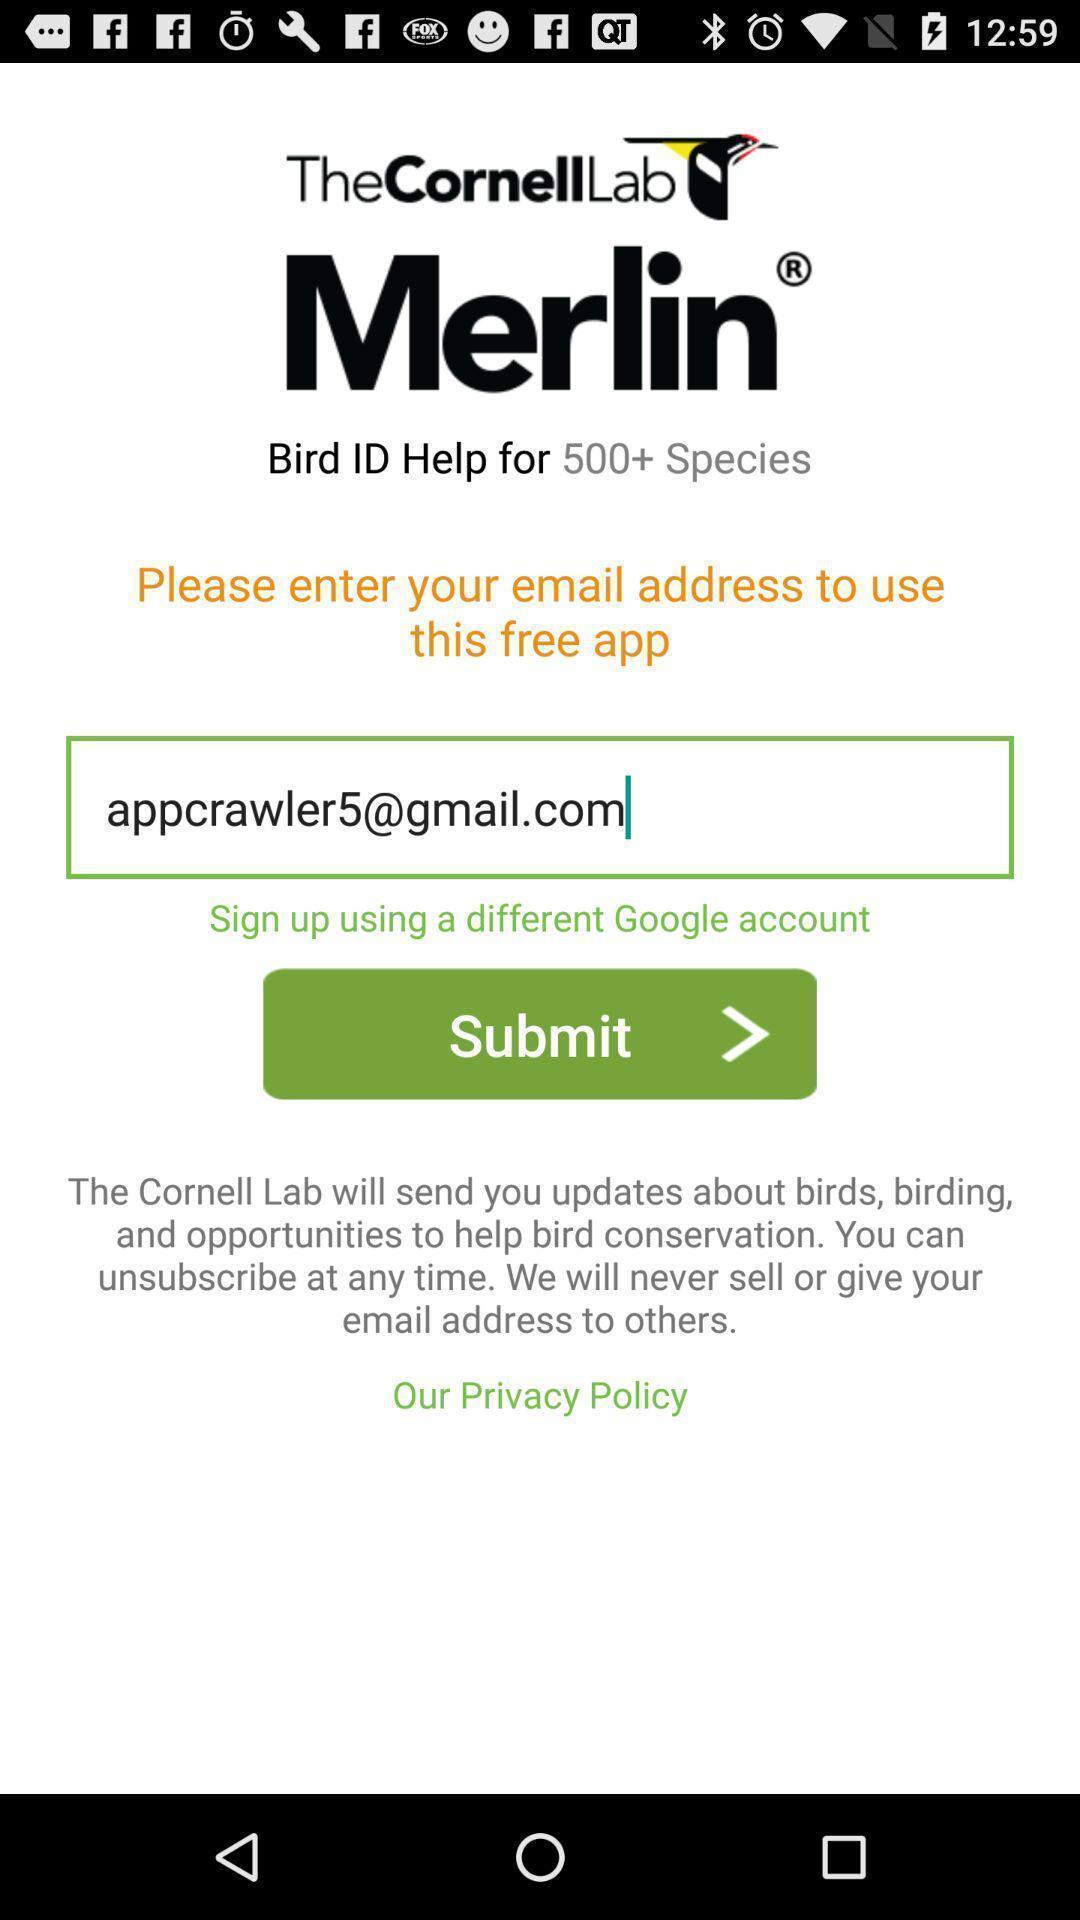Summarize the main components in this picture. Sign up page of a bird sighting app. 